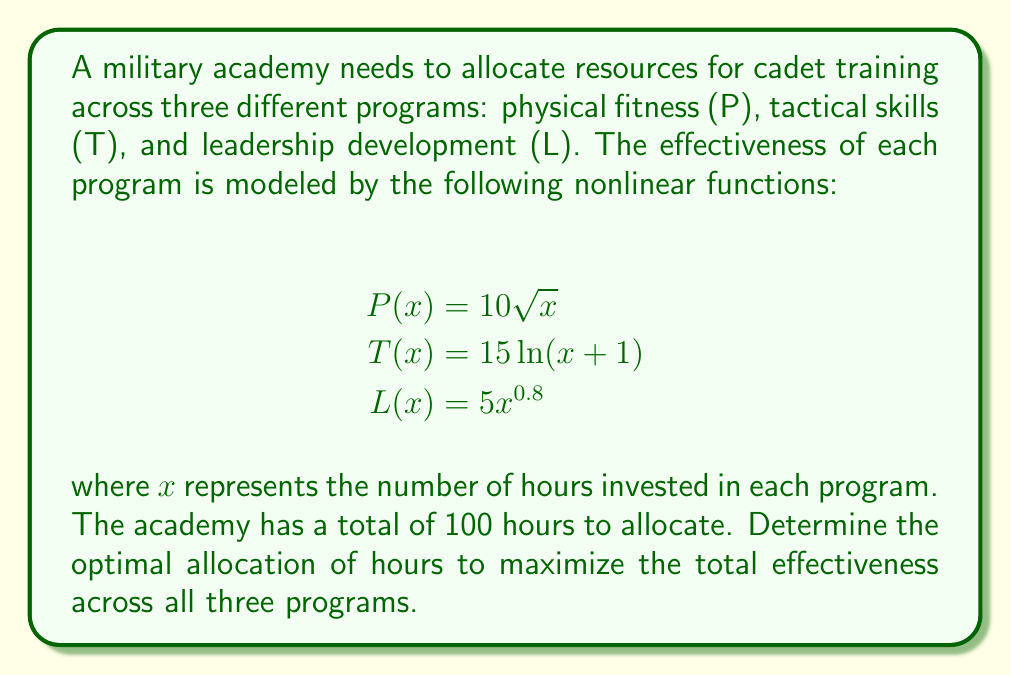Can you solve this math problem? To solve this problem, we'll use the method of Lagrange multipliers for constrained optimization.

Step 1: Define the objective function and constraint
Objective function: $f(x,y,z) = 10\sqrt{x} + 15\ln(y+1) + 5z^{0.8}$
Constraint: $g(x,y,z) = x + y + z - 100 = 0$

Step 2: Form the Lagrangian function
$L(x,y,z,\lambda) = 10\sqrt{x} + 15\ln(y+1) + 5z^{0.8} - \lambda(x + y + z - 100)$

Step 3: Take partial derivatives and set them equal to zero
$$\frac{\partial L}{\partial x} = \frac{5}{\sqrt{x}} - \lambda = 0$$
$$\frac{\partial L}{\partial y} = \frac{15}{y+1} - \lambda = 0$$
$$\frac{\partial L}{\partial z} = 4z^{-0.2} - \lambda = 0$$
$$\frac{\partial L}{\partial \lambda} = x + y + z - 100 = 0$$

Step 4: Solve the system of equations
From the first three equations:
$$\frac{5}{\sqrt{x}} = \frac{15}{y+1} = 4z^{-0.2} = \lambda$$

Let $\lambda = k$. Then:
$$x = \frac{25}{k^2}, y = \frac{15}{k} - 1, z = (\frac{4}{k})^5$$

Substitute these into the constraint equation:
$$\frac{25}{k^2} + \frac{15}{k} - 1 + (\frac{4}{k})^5 = 100$$

This equation can be solved numerically to find $k \approx 0.3162$.

Step 5: Calculate the optimal allocation
$$x \approx 250, y \approx 46.4, z \approx 1448.2$$

These values sum to more than 100, so we need to scale them down proportionally:
$$x \approx 14.33, y \approx 2.66, z \approx 83.01$$

Round to the nearest whole number:
$$x = 14, y = 3, z = 83$$
Answer: Physical fitness: 14 hours, Tactical skills: 3 hours, Leadership development: 83 hours 